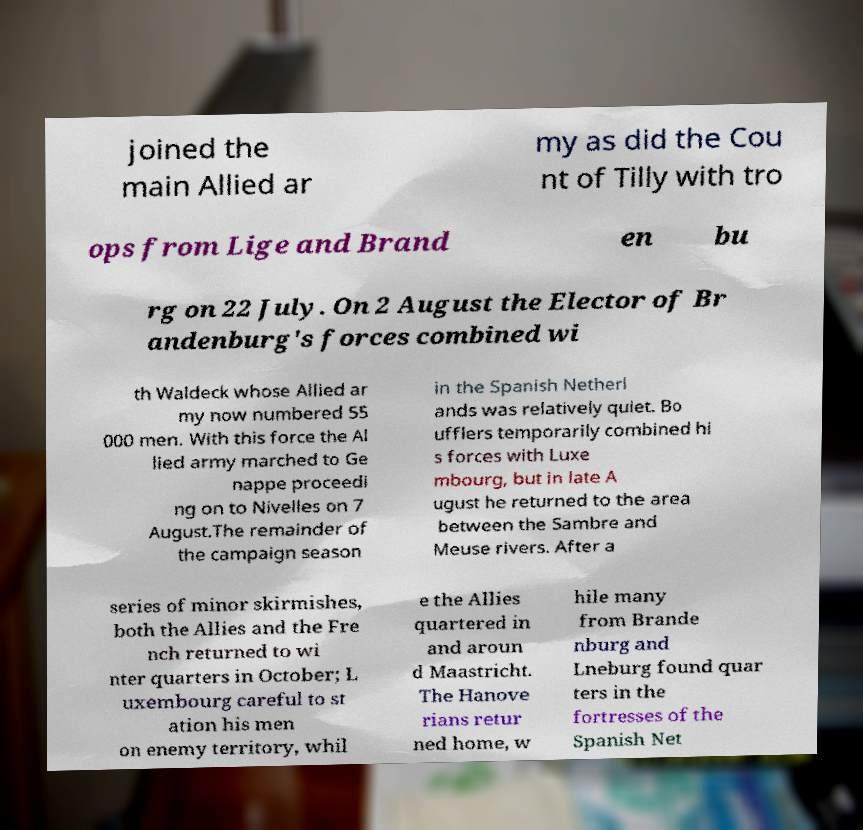Please read and relay the text visible in this image. What does it say? joined the main Allied ar my as did the Cou nt of Tilly with tro ops from Lige and Brand en bu rg on 22 July. On 2 August the Elector of Br andenburg's forces combined wi th Waldeck whose Allied ar my now numbered 55 000 men. With this force the Al lied army marched to Ge nappe proceedi ng on to Nivelles on 7 August.The remainder of the campaign season in the Spanish Netherl ands was relatively quiet. Bo ufflers temporarily combined hi s forces with Luxe mbourg, but in late A ugust he returned to the area between the Sambre and Meuse rivers. After a series of minor skirmishes, both the Allies and the Fre nch returned to wi nter quarters in October; L uxembourg careful to st ation his men on enemy territory, whil e the Allies quartered in and aroun d Maastricht. The Hanove rians retur ned home, w hile many from Brande nburg and Lneburg found quar ters in the fortresses of the Spanish Net 